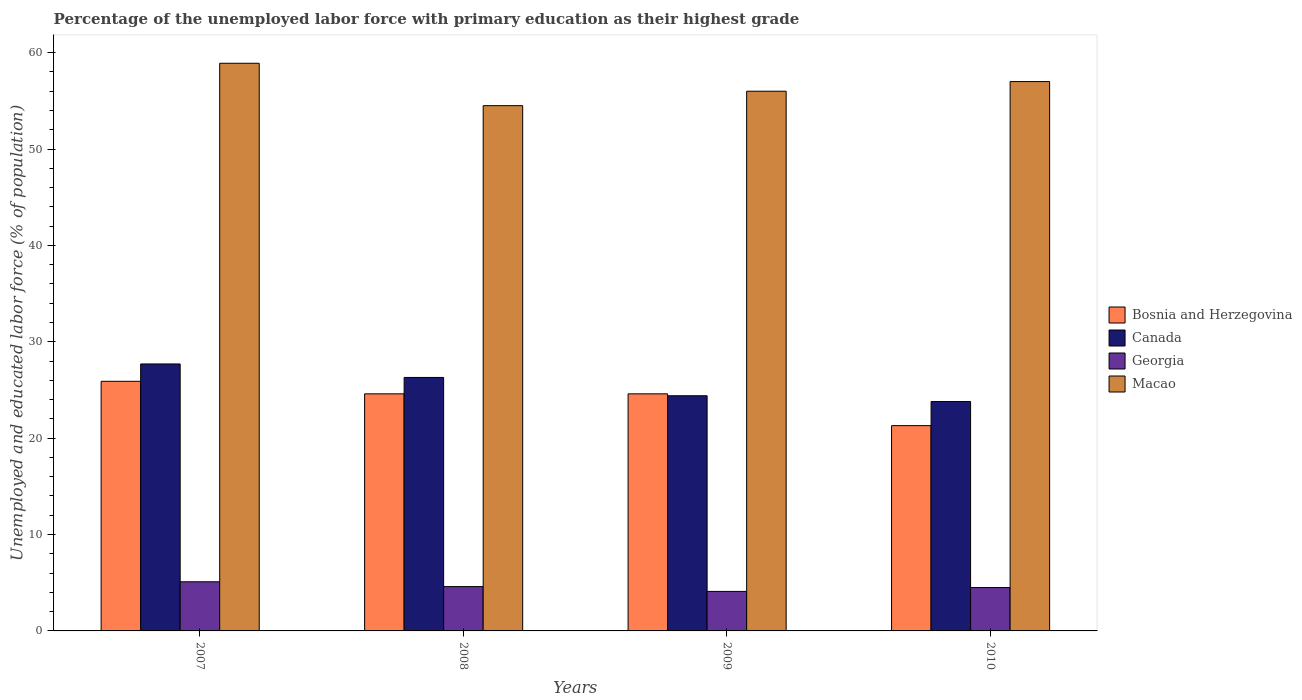How many different coloured bars are there?
Your response must be concise. 4. Are the number of bars per tick equal to the number of legend labels?
Your response must be concise. Yes. Are the number of bars on each tick of the X-axis equal?
Keep it short and to the point. Yes. How many bars are there on the 2nd tick from the right?
Provide a succinct answer. 4. What is the percentage of the unemployed labor force with primary education in Georgia in 2007?
Keep it short and to the point. 5.1. Across all years, what is the maximum percentage of the unemployed labor force with primary education in Macao?
Your response must be concise. 58.9. Across all years, what is the minimum percentage of the unemployed labor force with primary education in Georgia?
Your answer should be compact. 4.1. In which year was the percentage of the unemployed labor force with primary education in Macao minimum?
Provide a succinct answer. 2008. What is the total percentage of the unemployed labor force with primary education in Macao in the graph?
Give a very brief answer. 226.4. What is the difference between the percentage of the unemployed labor force with primary education in Georgia in 2007 and that in 2008?
Ensure brevity in your answer.  0.5. What is the difference between the percentage of the unemployed labor force with primary education in Canada in 2008 and the percentage of the unemployed labor force with primary education in Georgia in 2010?
Provide a short and direct response. 21.8. What is the average percentage of the unemployed labor force with primary education in Georgia per year?
Keep it short and to the point. 4.57. In the year 2007, what is the difference between the percentage of the unemployed labor force with primary education in Canada and percentage of the unemployed labor force with primary education in Bosnia and Herzegovina?
Offer a very short reply. 1.8. What is the ratio of the percentage of the unemployed labor force with primary education in Georgia in 2009 to that in 2010?
Provide a short and direct response. 0.91. Is the percentage of the unemployed labor force with primary education in Canada in 2008 less than that in 2009?
Offer a very short reply. No. Is the difference between the percentage of the unemployed labor force with primary education in Canada in 2008 and 2010 greater than the difference between the percentage of the unemployed labor force with primary education in Bosnia and Herzegovina in 2008 and 2010?
Keep it short and to the point. No. What is the difference between the highest and the second highest percentage of the unemployed labor force with primary education in Macao?
Your answer should be very brief. 1.9. What is the difference between the highest and the lowest percentage of the unemployed labor force with primary education in Georgia?
Offer a terse response. 1. In how many years, is the percentage of the unemployed labor force with primary education in Macao greater than the average percentage of the unemployed labor force with primary education in Macao taken over all years?
Give a very brief answer. 2. What does the 1st bar from the left in 2007 represents?
Provide a short and direct response. Bosnia and Herzegovina. What does the 4th bar from the right in 2008 represents?
Provide a short and direct response. Bosnia and Herzegovina. Is it the case that in every year, the sum of the percentage of the unemployed labor force with primary education in Macao and percentage of the unemployed labor force with primary education in Bosnia and Herzegovina is greater than the percentage of the unemployed labor force with primary education in Canada?
Make the answer very short. Yes. Are the values on the major ticks of Y-axis written in scientific E-notation?
Give a very brief answer. No. Does the graph contain any zero values?
Ensure brevity in your answer.  No. Does the graph contain grids?
Your answer should be compact. No. What is the title of the graph?
Provide a succinct answer. Percentage of the unemployed labor force with primary education as their highest grade. What is the label or title of the Y-axis?
Your response must be concise. Unemployed and educated labor force (% of population). What is the Unemployed and educated labor force (% of population) in Bosnia and Herzegovina in 2007?
Provide a succinct answer. 25.9. What is the Unemployed and educated labor force (% of population) of Canada in 2007?
Your answer should be very brief. 27.7. What is the Unemployed and educated labor force (% of population) of Georgia in 2007?
Provide a succinct answer. 5.1. What is the Unemployed and educated labor force (% of population) in Macao in 2007?
Your answer should be very brief. 58.9. What is the Unemployed and educated labor force (% of population) in Bosnia and Herzegovina in 2008?
Your response must be concise. 24.6. What is the Unemployed and educated labor force (% of population) in Canada in 2008?
Keep it short and to the point. 26.3. What is the Unemployed and educated labor force (% of population) of Georgia in 2008?
Keep it short and to the point. 4.6. What is the Unemployed and educated labor force (% of population) in Macao in 2008?
Give a very brief answer. 54.5. What is the Unemployed and educated labor force (% of population) in Bosnia and Herzegovina in 2009?
Provide a succinct answer. 24.6. What is the Unemployed and educated labor force (% of population) of Canada in 2009?
Ensure brevity in your answer.  24.4. What is the Unemployed and educated labor force (% of population) in Georgia in 2009?
Your answer should be compact. 4.1. What is the Unemployed and educated labor force (% of population) of Macao in 2009?
Make the answer very short. 56. What is the Unemployed and educated labor force (% of population) of Bosnia and Herzegovina in 2010?
Offer a terse response. 21.3. What is the Unemployed and educated labor force (% of population) of Canada in 2010?
Offer a very short reply. 23.8. What is the Unemployed and educated labor force (% of population) in Georgia in 2010?
Your answer should be compact. 4.5. What is the Unemployed and educated labor force (% of population) in Macao in 2010?
Make the answer very short. 57. Across all years, what is the maximum Unemployed and educated labor force (% of population) in Bosnia and Herzegovina?
Ensure brevity in your answer.  25.9. Across all years, what is the maximum Unemployed and educated labor force (% of population) of Canada?
Offer a terse response. 27.7. Across all years, what is the maximum Unemployed and educated labor force (% of population) of Georgia?
Offer a terse response. 5.1. Across all years, what is the maximum Unemployed and educated labor force (% of population) of Macao?
Ensure brevity in your answer.  58.9. Across all years, what is the minimum Unemployed and educated labor force (% of population) in Bosnia and Herzegovina?
Provide a short and direct response. 21.3. Across all years, what is the minimum Unemployed and educated labor force (% of population) in Canada?
Your response must be concise. 23.8. Across all years, what is the minimum Unemployed and educated labor force (% of population) in Georgia?
Your response must be concise. 4.1. Across all years, what is the minimum Unemployed and educated labor force (% of population) of Macao?
Keep it short and to the point. 54.5. What is the total Unemployed and educated labor force (% of population) in Bosnia and Herzegovina in the graph?
Give a very brief answer. 96.4. What is the total Unemployed and educated labor force (% of population) in Canada in the graph?
Your answer should be compact. 102.2. What is the total Unemployed and educated labor force (% of population) in Macao in the graph?
Your response must be concise. 226.4. What is the difference between the Unemployed and educated labor force (% of population) in Canada in 2007 and that in 2008?
Your answer should be very brief. 1.4. What is the difference between the Unemployed and educated labor force (% of population) in Georgia in 2007 and that in 2008?
Your response must be concise. 0.5. What is the difference between the Unemployed and educated labor force (% of population) in Bosnia and Herzegovina in 2007 and that in 2009?
Your answer should be compact. 1.3. What is the difference between the Unemployed and educated labor force (% of population) in Canada in 2007 and that in 2009?
Provide a short and direct response. 3.3. What is the difference between the Unemployed and educated labor force (% of population) of Georgia in 2007 and that in 2009?
Your response must be concise. 1. What is the difference between the Unemployed and educated labor force (% of population) in Bosnia and Herzegovina in 2007 and that in 2010?
Give a very brief answer. 4.6. What is the difference between the Unemployed and educated labor force (% of population) of Canada in 2007 and that in 2010?
Your answer should be compact. 3.9. What is the difference between the Unemployed and educated labor force (% of population) in Macao in 2007 and that in 2010?
Keep it short and to the point. 1.9. What is the difference between the Unemployed and educated labor force (% of population) in Georgia in 2008 and that in 2009?
Provide a short and direct response. 0.5. What is the difference between the Unemployed and educated labor force (% of population) of Macao in 2008 and that in 2010?
Offer a very short reply. -2.5. What is the difference between the Unemployed and educated labor force (% of population) of Georgia in 2009 and that in 2010?
Keep it short and to the point. -0.4. What is the difference between the Unemployed and educated labor force (% of population) of Bosnia and Herzegovina in 2007 and the Unemployed and educated labor force (% of population) of Canada in 2008?
Your answer should be compact. -0.4. What is the difference between the Unemployed and educated labor force (% of population) of Bosnia and Herzegovina in 2007 and the Unemployed and educated labor force (% of population) of Georgia in 2008?
Offer a terse response. 21.3. What is the difference between the Unemployed and educated labor force (% of population) in Bosnia and Herzegovina in 2007 and the Unemployed and educated labor force (% of population) in Macao in 2008?
Make the answer very short. -28.6. What is the difference between the Unemployed and educated labor force (% of population) in Canada in 2007 and the Unemployed and educated labor force (% of population) in Georgia in 2008?
Ensure brevity in your answer.  23.1. What is the difference between the Unemployed and educated labor force (% of population) of Canada in 2007 and the Unemployed and educated labor force (% of population) of Macao in 2008?
Ensure brevity in your answer.  -26.8. What is the difference between the Unemployed and educated labor force (% of population) of Georgia in 2007 and the Unemployed and educated labor force (% of population) of Macao in 2008?
Your response must be concise. -49.4. What is the difference between the Unemployed and educated labor force (% of population) in Bosnia and Herzegovina in 2007 and the Unemployed and educated labor force (% of population) in Georgia in 2009?
Keep it short and to the point. 21.8. What is the difference between the Unemployed and educated labor force (% of population) of Bosnia and Herzegovina in 2007 and the Unemployed and educated labor force (% of population) of Macao in 2009?
Make the answer very short. -30.1. What is the difference between the Unemployed and educated labor force (% of population) of Canada in 2007 and the Unemployed and educated labor force (% of population) of Georgia in 2009?
Your answer should be very brief. 23.6. What is the difference between the Unemployed and educated labor force (% of population) in Canada in 2007 and the Unemployed and educated labor force (% of population) in Macao in 2009?
Your answer should be compact. -28.3. What is the difference between the Unemployed and educated labor force (% of population) of Georgia in 2007 and the Unemployed and educated labor force (% of population) of Macao in 2009?
Provide a succinct answer. -50.9. What is the difference between the Unemployed and educated labor force (% of population) in Bosnia and Herzegovina in 2007 and the Unemployed and educated labor force (% of population) in Canada in 2010?
Your answer should be compact. 2.1. What is the difference between the Unemployed and educated labor force (% of population) in Bosnia and Herzegovina in 2007 and the Unemployed and educated labor force (% of population) in Georgia in 2010?
Offer a terse response. 21.4. What is the difference between the Unemployed and educated labor force (% of population) of Bosnia and Herzegovina in 2007 and the Unemployed and educated labor force (% of population) of Macao in 2010?
Provide a short and direct response. -31.1. What is the difference between the Unemployed and educated labor force (% of population) of Canada in 2007 and the Unemployed and educated labor force (% of population) of Georgia in 2010?
Make the answer very short. 23.2. What is the difference between the Unemployed and educated labor force (% of population) of Canada in 2007 and the Unemployed and educated labor force (% of population) of Macao in 2010?
Offer a terse response. -29.3. What is the difference between the Unemployed and educated labor force (% of population) of Georgia in 2007 and the Unemployed and educated labor force (% of population) of Macao in 2010?
Your answer should be compact. -51.9. What is the difference between the Unemployed and educated labor force (% of population) of Bosnia and Herzegovina in 2008 and the Unemployed and educated labor force (% of population) of Georgia in 2009?
Give a very brief answer. 20.5. What is the difference between the Unemployed and educated labor force (% of population) of Bosnia and Herzegovina in 2008 and the Unemployed and educated labor force (% of population) of Macao in 2009?
Provide a succinct answer. -31.4. What is the difference between the Unemployed and educated labor force (% of population) of Canada in 2008 and the Unemployed and educated labor force (% of population) of Macao in 2009?
Give a very brief answer. -29.7. What is the difference between the Unemployed and educated labor force (% of population) in Georgia in 2008 and the Unemployed and educated labor force (% of population) in Macao in 2009?
Provide a succinct answer. -51.4. What is the difference between the Unemployed and educated labor force (% of population) in Bosnia and Herzegovina in 2008 and the Unemployed and educated labor force (% of population) in Georgia in 2010?
Make the answer very short. 20.1. What is the difference between the Unemployed and educated labor force (% of population) of Bosnia and Herzegovina in 2008 and the Unemployed and educated labor force (% of population) of Macao in 2010?
Provide a short and direct response. -32.4. What is the difference between the Unemployed and educated labor force (% of population) in Canada in 2008 and the Unemployed and educated labor force (% of population) in Georgia in 2010?
Your answer should be very brief. 21.8. What is the difference between the Unemployed and educated labor force (% of population) of Canada in 2008 and the Unemployed and educated labor force (% of population) of Macao in 2010?
Offer a very short reply. -30.7. What is the difference between the Unemployed and educated labor force (% of population) in Georgia in 2008 and the Unemployed and educated labor force (% of population) in Macao in 2010?
Provide a short and direct response. -52.4. What is the difference between the Unemployed and educated labor force (% of population) in Bosnia and Herzegovina in 2009 and the Unemployed and educated labor force (% of population) in Canada in 2010?
Give a very brief answer. 0.8. What is the difference between the Unemployed and educated labor force (% of population) in Bosnia and Herzegovina in 2009 and the Unemployed and educated labor force (% of population) in Georgia in 2010?
Provide a short and direct response. 20.1. What is the difference between the Unemployed and educated labor force (% of population) in Bosnia and Herzegovina in 2009 and the Unemployed and educated labor force (% of population) in Macao in 2010?
Make the answer very short. -32.4. What is the difference between the Unemployed and educated labor force (% of population) of Canada in 2009 and the Unemployed and educated labor force (% of population) of Georgia in 2010?
Keep it short and to the point. 19.9. What is the difference between the Unemployed and educated labor force (% of population) in Canada in 2009 and the Unemployed and educated labor force (% of population) in Macao in 2010?
Keep it short and to the point. -32.6. What is the difference between the Unemployed and educated labor force (% of population) of Georgia in 2009 and the Unemployed and educated labor force (% of population) of Macao in 2010?
Offer a terse response. -52.9. What is the average Unemployed and educated labor force (% of population) in Bosnia and Herzegovina per year?
Your response must be concise. 24.1. What is the average Unemployed and educated labor force (% of population) in Canada per year?
Offer a terse response. 25.55. What is the average Unemployed and educated labor force (% of population) of Georgia per year?
Keep it short and to the point. 4.58. What is the average Unemployed and educated labor force (% of population) of Macao per year?
Offer a terse response. 56.6. In the year 2007, what is the difference between the Unemployed and educated labor force (% of population) in Bosnia and Herzegovina and Unemployed and educated labor force (% of population) in Canada?
Make the answer very short. -1.8. In the year 2007, what is the difference between the Unemployed and educated labor force (% of population) in Bosnia and Herzegovina and Unemployed and educated labor force (% of population) in Georgia?
Provide a short and direct response. 20.8. In the year 2007, what is the difference between the Unemployed and educated labor force (% of population) in Bosnia and Herzegovina and Unemployed and educated labor force (% of population) in Macao?
Your answer should be very brief. -33. In the year 2007, what is the difference between the Unemployed and educated labor force (% of population) in Canada and Unemployed and educated labor force (% of population) in Georgia?
Give a very brief answer. 22.6. In the year 2007, what is the difference between the Unemployed and educated labor force (% of population) of Canada and Unemployed and educated labor force (% of population) of Macao?
Your answer should be compact. -31.2. In the year 2007, what is the difference between the Unemployed and educated labor force (% of population) in Georgia and Unemployed and educated labor force (% of population) in Macao?
Your response must be concise. -53.8. In the year 2008, what is the difference between the Unemployed and educated labor force (% of population) of Bosnia and Herzegovina and Unemployed and educated labor force (% of population) of Georgia?
Your answer should be compact. 20. In the year 2008, what is the difference between the Unemployed and educated labor force (% of population) of Bosnia and Herzegovina and Unemployed and educated labor force (% of population) of Macao?
Offer a very short reply. -29.9. In the year 2008, what is the difference between the Unemployed and educated labor force (% of population) of Canada and Unemployed and educated labor force (% of population) of Georgia?
Your answer should be compact. 21.7. In the year 2008, what is the difference between the Unemployed and educated labor force (% of population) in Canada and Unemployed and educated labor force (% of population) in Macao?
Offer a very short reply. -28.2. In the year 2008, what is the difference between the Unemployed and educated labor force (% of population) of Georgia and Unemployed and educated labor force (% of population) of Macao?
Keep it short and to the point. -49.9. In the year 2009, what is the difference between the Unemployed and educated labor force (% of population) of Bosnia and Herzegovina and Unemployed and educated labor force (% of population) of Georgia?
Give a very brief answer. 20.5. In the year 2009, what is the difference between the Unemployed and educated labor force (% of population) of Bosnia and Herzegovina and Unemployed and educated labor force (% of population) of Macao?
Provide a succinct answer. -31.4. In the year 2009, what is the difference between the Unemployed and educated labor force (% of population) in Canada and Unemployed and educated labor force (% of population) in Georgia?
Provide a short and direct response. 20.3. In the year 2009, what is the difference between the Unemployed and educated labor force (% of population) in Canada and Unemployed and educated labor force (% of population) in Macao?
Your answer should be very brief. -31.6. In the year 2009, what is the difference between the Unemployed and educated labor force (% of population) of Georgia and Unemployed and educated labor force (% of population) of Macao?
Offer a terse response. -51.9. In the year 2010, what is the difference between the Unemployed and educated labor force (% of population) in Bosnia and Herzegovina and Unemployed and educated labor force (% of population) in Georgia?
Your response must be concise. 16.8. In the year 2010, what is the difference between the Unemployed and educated labor force (% of population) in Bosnia and Herzegovina and Unemployed and educated labor force (% of population) in Macao?
Provide a short and direct response. -35.7. In the year 2010, what is the difference between the Unemployed and educated labor force (% of population) of Canada and Unemployed and educated labor force (% of population) of Georgia?
Ensure brevity in your answer.  19.3. In the year 2010, what is the difference between the Unemployed and educated labor force (% of population) of Canada and Unemployed and educated labor force (% of population) of Macao?
Keep it short and to the point. -33.2. In the year 2010, what is the difference between the Unemployed and educated labor force (% of population) of Georgia and Unemployed and educated labor force (% of population) of Macao?
Your answer should be compact. -52.5. What is the ratio of the Unemployed and educated labor force (% of population) of Bosnia and Herzegovina in 2007 to that in 2008?
Keep it short and to the point. 1.05. What is the ratio of the Unemployed and educated labor force (% of population) of Canada in 2007 to that in 2008?
Make the answer very short. 1.05. What is the ratio of the Unemployed and educated labor force (% of population) in Georgia in 2007 to that in 2008?
Your response must be concise. 1.11. What is the ratio of the Unemployed and educated labor force (% of population) of Macao in 2007 to that in 2008?
Give a very brief answer. 1.08. What is the ratio of the Unemployed and educated labor force (% of population) in Bosnia and Herzegovina in 2007 to that in 2009?
Keep it short and to the point. 1.05. What is the ratio of the Unemployed and educated labor force (% of population) of Canada in 2007 to that in 2009?
Offer a terse response. 1.14. What is the ratio of the Unemployed and educated labor force (% of population) of Georgia in 2007 to that in 2009?
Ensure brevity in your answer.  1.24. What is the ratio of the Unemployed and educated labor force (% of population) of Macao in 2007 to that in 2009?
Provide a short and direct response. 1.05. What is the ratio of the Unemployed and educated labor force (% of population) of Bosnia and Herzegovina in 2007 to that in 2010?
Make the answer very short. 1.22. What is the ratio of the Unemployed and educated labor force (% of population) of Canada in 2007 to that in 2010?
Ensure brevity in your answer.  1.16. What is the ratio of the Unemployed and educated labor force (% of population) of Georgia in 2007 to that in 2010?
Keep it short and to the point. 1.13. What is the ratio of the Unemployed and educated labor force (% of population) in Macao in 2007 to that in 2010?
Give a very brief answer. 1.03. What is the ratio of the Unemployed and educated labor force (% of population) in Canada in 2008 to that in 2009?
Give a very brief answer. 1.08. What is the ratio of the Unemployed and educated labor force (% of population) of Georgia in 2008 to that in 2009?
Offer a terse response. 1.12. What is the ratio of the Unemployed and educated labor force (% of population) of Macao in 2008 to that in 2009?
Offer a very short reply. 0.97. What is the ratio of the Unemployed and educated labor force (% of population) in Bosnia and Herzegovina in 2008 to that in 2010?
Keep it short and to the point. 1.15. What is the ratio of the Unemployed and educated labor force (% of population) in Canada in 2008 to that in 2010?
Make the answer very short. 1.1. What is the ratio of the Unemployed and educated labor force (% of population) in Georgia in 2008 to that in 2010?
Ensure brevity in your answer.  1.02. What is the ratio of the Unemployed and educated labor force (% of population) of Macao in 2008 to that in 2010?
Ensure brevity in your answer.  0.96. What is the ratio of the Unemployed and educated labor force (% of population) of Bosnia and Herzegovina in 2009 to that in 2010?
Offer a very short reply. 1.15. What is the ratio of the Unemployed and educated labor force (% of population) in Canada in 2009 to that in 2010?
Give a very brief answer. 1.03. What is the ratio of the Unemployed and educated labor force (% of population) in Georgia in 2009 to that in 2010?
Ensure brevity in your answer.  0.91. What is the ratio of the Unemployed and educated labor force (% of population) in Macao in 2009 to that in 2010?
Your answer should be very brief. 0.98. What is the difference between the highest and the second highest Unemployed and educated labor force (% of population) of Canada?
Keep it short and to the point. 1.4. What is the difference between the highest and the second highest Unemployed and educated labor force (% of population) of Georgia?
Ensure brevity in your answer.  0.5. What is the difference between the highest and the lowest Unemployed and educated labor force (% of population) in Bosnia and Herzegovina?
Make the answer very short. 4.6. What is the difference between the highest and the lowest Unemployed and educated labor force (% of population) in Georgia?
Make the answer very short. 1. 